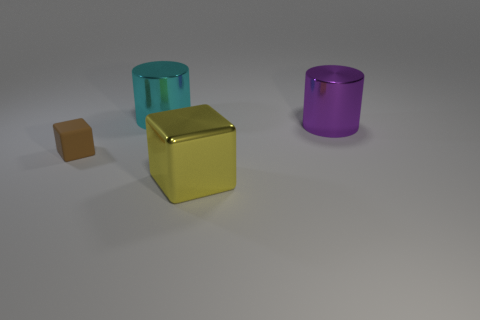How many objects are both behind the tiny brown matte cube and on the left side of the big yellow cube?
Provide a succinct answer. 1. There is a large purple metallic cylinder; what number of large cylinders are left of it?
Keep it short and to the point. 1. Are there any other objects that have the same shape as the purple thing?
Offer a terse response. Yes. There is a large cyan shiny object; is it the same shape as the shiny thing that is on the right side of the big yellow thing?
Offer a very short reply. Yes. What number of cylinders are either large purple shiny objects or big cyan things?
Your answer should be compact. 2. There is a big object to the left of the large yellow shiny thing; what is its shape?
Ensure brevity in your answer.  Cylinder. How many other objects have the same material as the large yellow object?
Keep it short and to the point. 2. Are there fewer large purple cylinders that are on the right side of the purple metal object than large cylinders?
Your answer should be compact. Yes. What size is the metallic thing that is behind the shiny cylinder that is right of the large cyan shiny thing?
Provide a short and direct response. Large. There is a block that is the same size as the cyan shiny thing; what is it made of?
Your answer should be compact. Metal. 